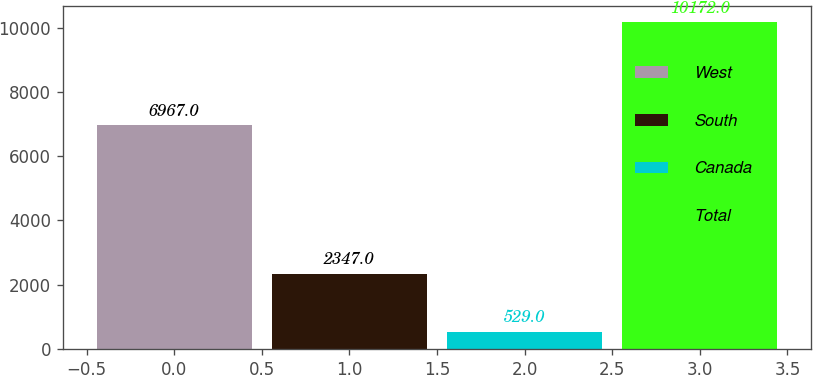Convert chart to OTSL. <chart><loc_0><loc_0><loc_500><loc_500><bar_chart><fcel>West<fcel>South<fcel>Canada<fcel>Total<nl><fcel>6967<fcel>2347<fcel>529<fcel>10172<nl></chart> 